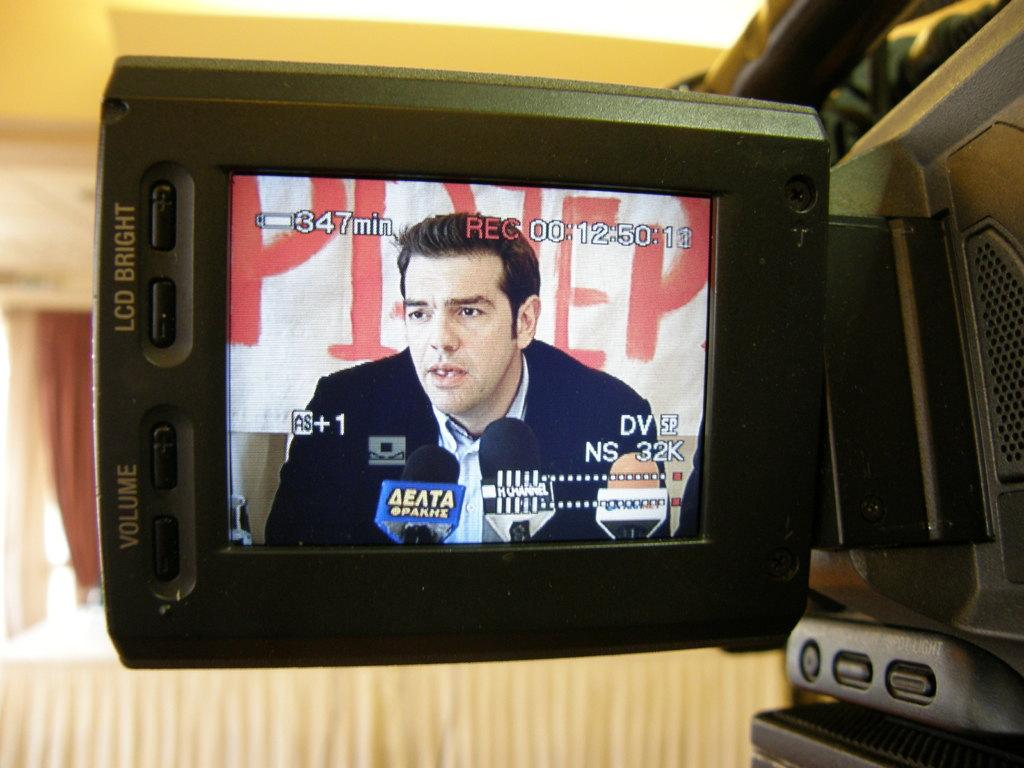<image>
Give a short and clear explanation of the subsequent image. A video camera display screen shows that this recording is 357 minutes long. 